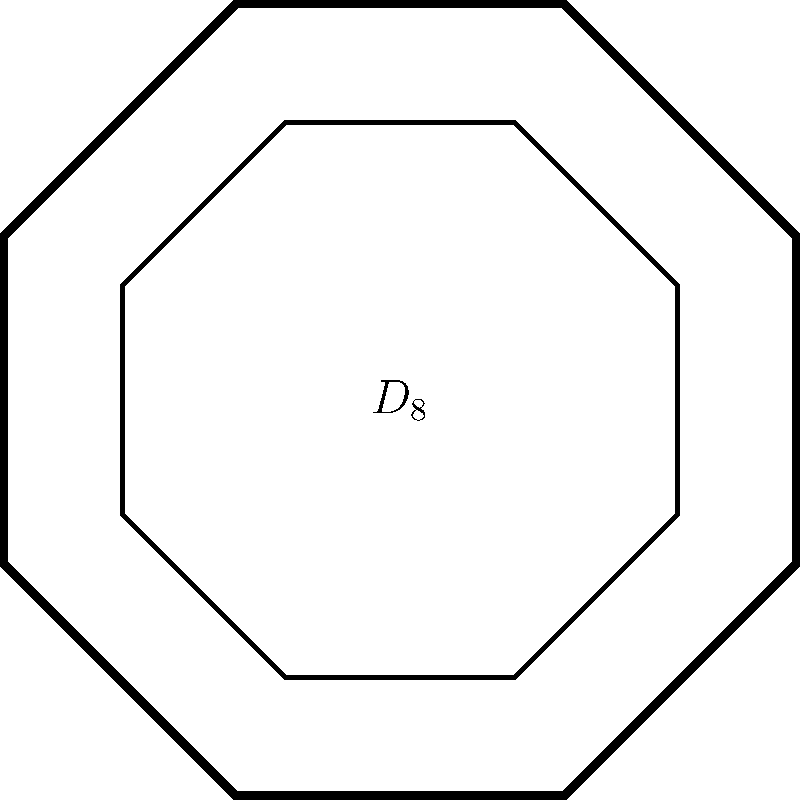A historical legal document features a coat of arms with an octagonal shape, as shown in the diagram. The dihedral group $D_8$ represents the symmetries of this coat of arms. How many elements are in the group $D_8$, and what types of transformations do these elements represent? To determine the number of elements in the dihedral group $D_8$ and understand the types of transformations they represent, let's follow these steps:

1. The dihedral group $D_n$ represents the symmetries of a regular n-gon. In this case, we have an octagon, so $n = 8$.

2. The elements of $D_8$ consist of two types of transformations:
   a) Rotations
   b) Reflections

3. Rotations:
   - There are 8 rotations possible, including the identity rotation (0°):
   - Rotation angles: 0°, 45°, 90°, 135°, 180°, 225°, 270°, 315°
   - Total number of rotations: 8

4. Reflections:
   - There are 8 lines of reflection in an octagon:
   - 4 passing through opposite vertices
   - 4 passing through the midpoints of opposite sides
   - Total number of reflections: 8

5. Total number of elements in $D_8$:
   $|D_8| = \text{Number of rotations} + \text{Number of reflections}$
   $|D_8| = 8 + 8 = 16$

Therefore, the dihedral group $D_8$ has 16 elements, consisting of 8 rotations and 8 reflections.
Answer: 16 elements: 8 rotations and 8 reflections 